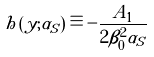<formula> <loc_0><loc_0><loc_500><loc_500>h \left ( y ; \alpha _ { S } \right ) \equiv - \frac { A _ { 1 } } { 2 \beta _ { 0 } ^ { 2 } \alpha _ { S } }</formula> 